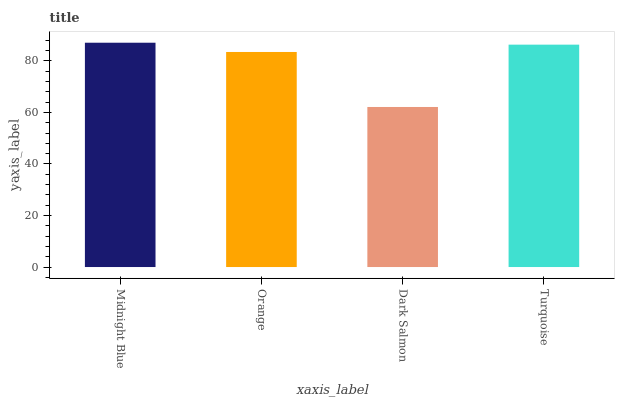Is Dark Salmon the minimum?
Answer yes or no. Yes. Is Midnight Blue the maximum?
Answer yes or no. Yes. Is Orange the minimum?
Answer yes or no. No. Is Orange the maximum?
Answer yes or no. No. Is Midnight Blue greater than Orange?
Answer yes or no. Yes. Is Orange less than Midnight Blue?
Answer yes or no. Yes. Is Orange greater than Midnight Blue?
Answer yes or no. No. Is Midnight Blue less than Orange?
Answer yes or no. No. Is Turquoise the high median?
Answer yes or no. Yes. Is Orange the low median?
Answer yes or no. Yes. Is Orange the high median?
Answer yes or no. No. Is Dark Salmon the low median?
Answer yes or no. No. 